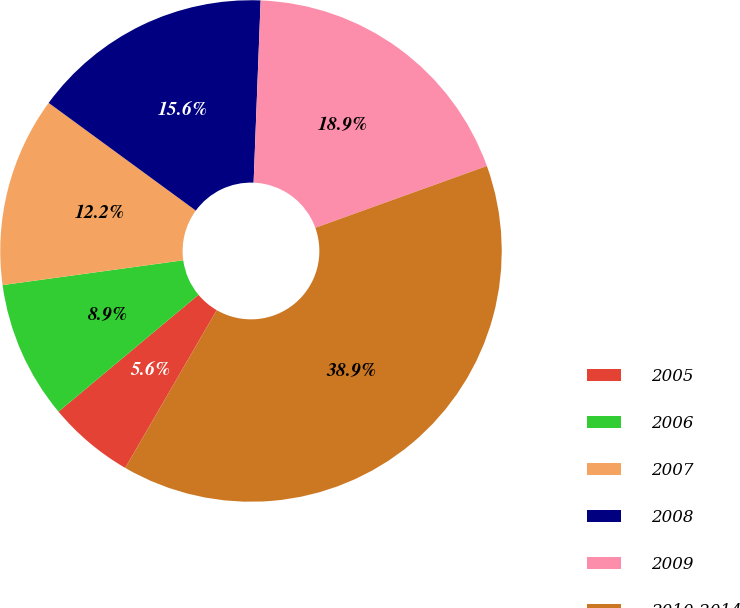<chart> <loc_0><loc_0><loc_500><loc_500><pie_chart><fcel>2005<fcel>2006<fcel>2007<fcel>2008<fcel>2009<fcel>2010-2014<nl><fcel>5.57%<fcel>8.9%<fcel>12.23%<fcel>15.56%<fcel>18.89%<fcel>38.87%<nl></chart> 